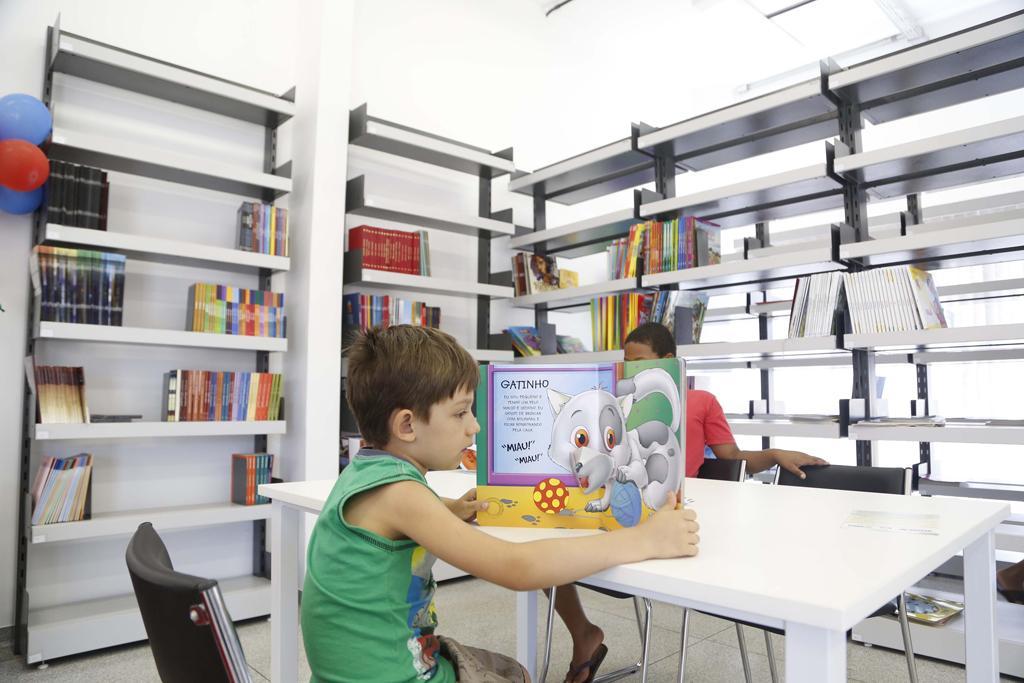Describe this image in one or two sentences. in the picture there was a room a was boy sitting in the chair and reading a book placing it on the table,another boy was sitting a little bit away,in the room their was shelf,in the shelf there was books. 